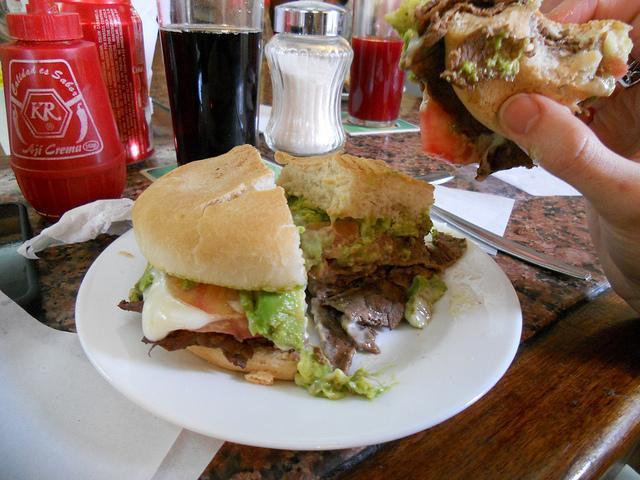How many condiment containers are shown?
Give a very brief answer. 2. How many cups are in the photo?
Give a very brief answer. 2. How many sandwiches are there?
Give a very brief answer. 2. How many people are visible?
Give a very brief answer. 1. 